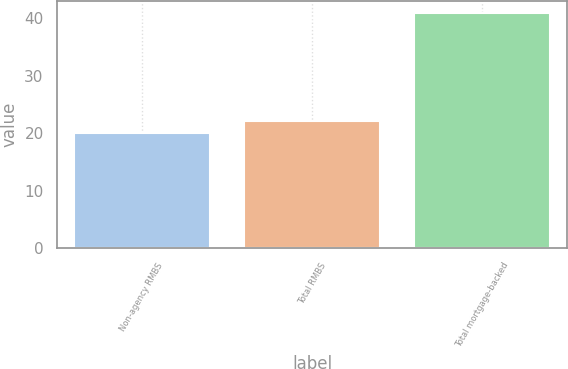Convert chart. <chart><loc_0><loc_0><loc_500><loc_500><bar_chart><fcel>Non-agency RMBS<fcel>Total RMBS<fcel>Total mortgage-backed<nl><fcel>20<fcel>22.1<fcel>41<nl></chart> 